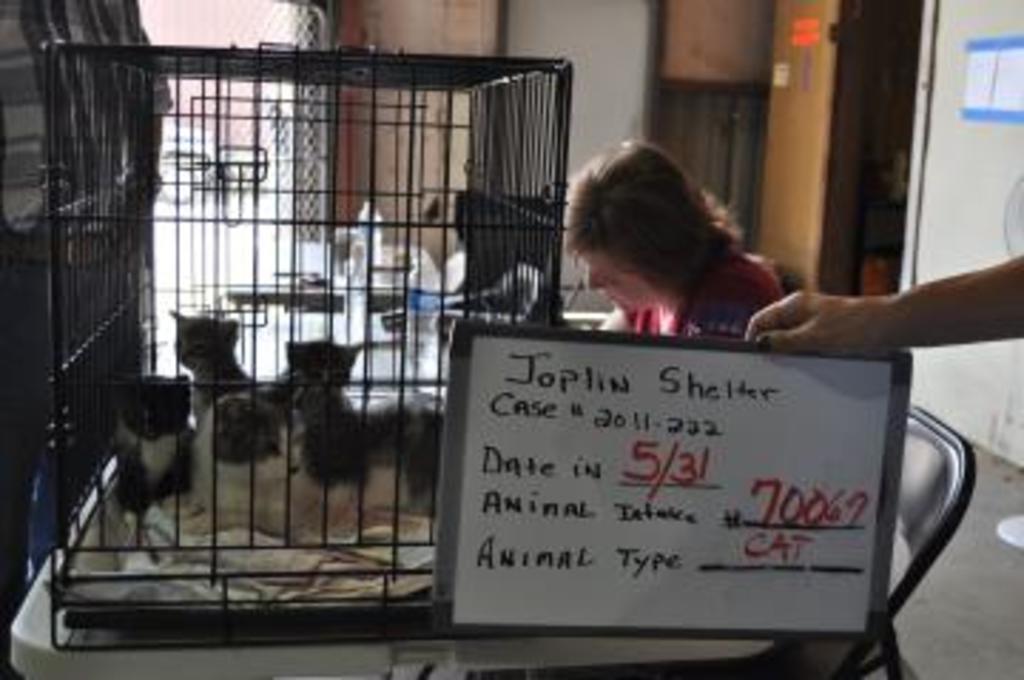Describe this image in one or two sentences. In the picture we can see a table on it we can see a cage with some cats in it and near the table we can see a woman sitting and just beside her we can see a person hand holding some board with some information on it and behind her we can see a wall with entrance. 